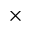<formula> <loc_0><loc_0><loc_500><loc_500>\times</formula> 